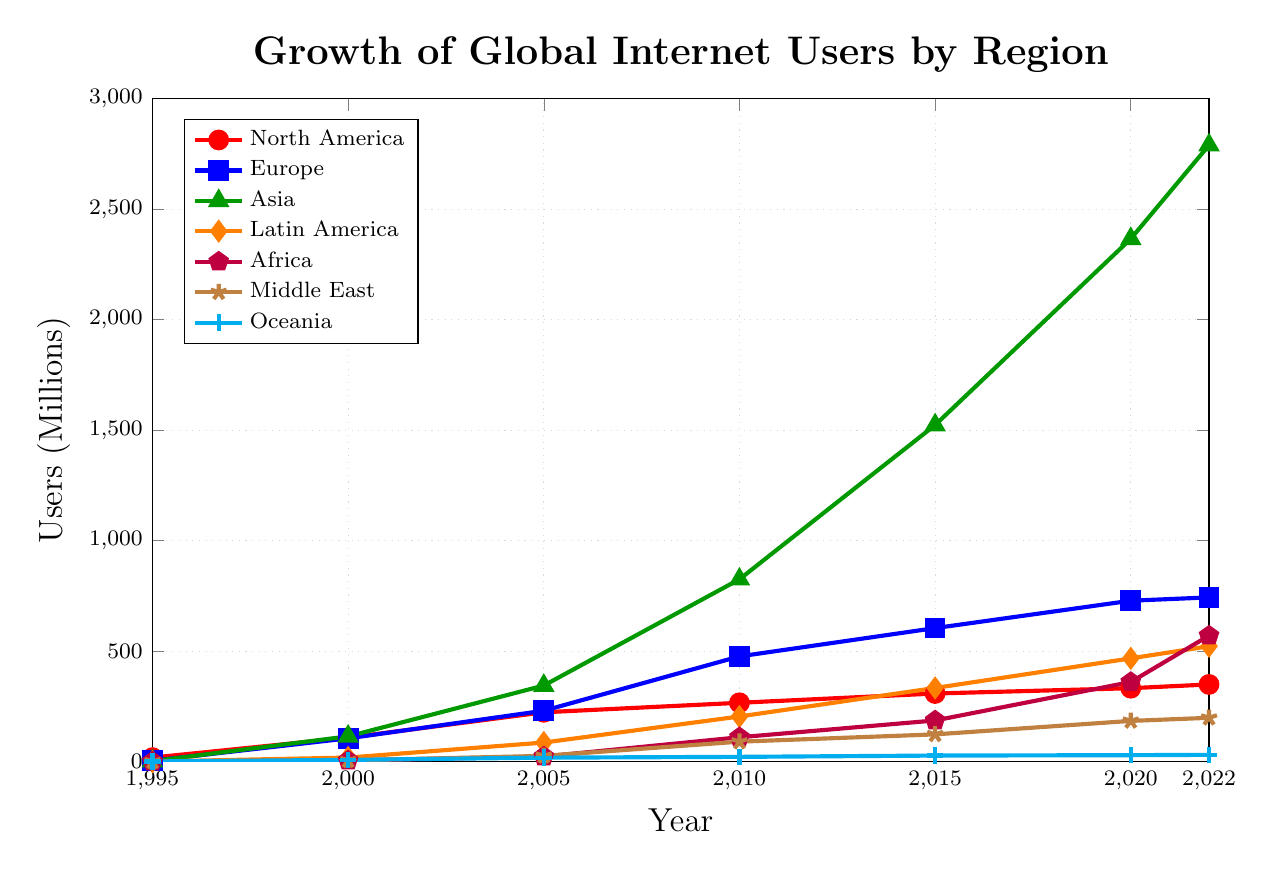Which region had the highest number of internet users in 2022? By observing the plot, the green line marked with triangles, representing Asia, reaches the highest point on the y-axis in 2022.
Answer: Asia How many more internet users were there in North America than in the Middle East in 2000? In 2000, the plot shows North America with 108 million users and the Middle East with 5.2 million users. The difference is calculated as 108 - 5.2.
Answer: 102.8 million What is the average number of internet users in Latin America from 2000 to 2022? Add the values of Latin America for 2000, 2005, 2010, 2015, 2020, and 2022: 18, 86, 204, 333, 467, and 522. Then, divide by the number of points, which is 6. The calculation is (18 + 86 + 204 + 333 + 467 + 522) / 6.
Answer: 271.67 million Between which consecutive years did Europe experience the largest increase in internet users? By observing the blue line marked with squares, the steepest rise appears between 2005 and 2010. To verify, calculate the increase between consecutive years for Europe: (105 - 4) for 1995 to 2000, (230 - 105) for 2000 to 2005, (476 - 230) for 2005 to 2010, etc. The largest increase is between 2005 and 2010.
Answer: 2005 and 2010 Which region had the least growth in internet users between 2015 and 2020? Compare the growth for each region by subtracting the number of users in 2015 from those in 2020. The difference for Oceania is minimal, indicating the least growth.
Answer: Oceania How many internet users were there in Asia in 2015 compared to the total number in North America and Europe combined in 2010? In 2015, Asia had 1523 million users. In 2010, North America had 266 million and Europe had 476 million, summing to 742 million. Compare 1523 million to 742 million.
Answer: Asia had 781 million more users What is the rate of increase for Africa's internet users from 1995 to 2022? Calculating the rate of increase involves the initial and final values. In 1995, Africa had 0.02 million users and in 2022, it had 570 million users. The rate of increase is (570 - 0.02) / 0.02.
Answer: 28499 times How does the number of internet users in the Middle East in 2020 compare to the number in Latin America in 2000? The plot shows 184 million users in the Middle East in 2020 and 18 million users in Latin America in 2000. The Middle East had more users.
Answer: The Middle East had 166 million more users 